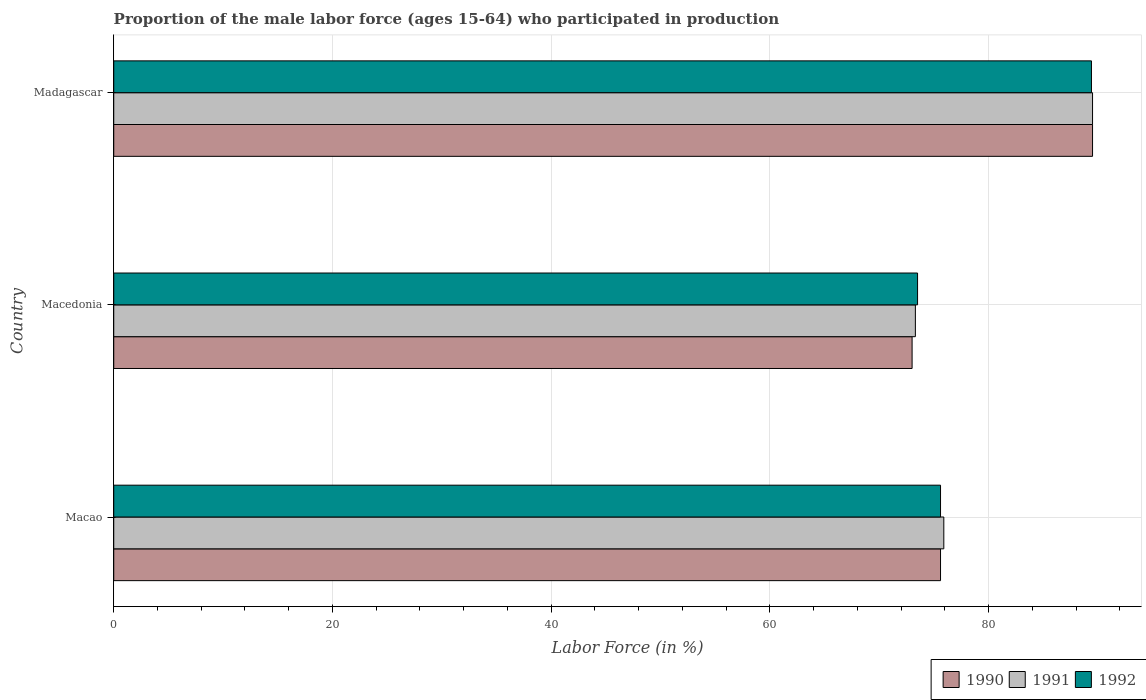How many different coloured bars are there?
Your answer should be compact. 3. Are the number of bars per tick equal to the number of legend labels?
Provide a short and direct response. Yes. Are the number of bars on each tick of the Y-axis equal?
Keep it short and to the point. Yes. How many bars are there on the 3rd tick from the top?
Offer a very short reply. 3. How many bars are there on the 3rd tick from the bottom?
Give a very brief answer. 3. What is the label of the 3rd group of bars from the top?
Offer a terse response. Macao. In how many cases, is the number of bars for a given country not equal to the number of legend labels?
Give a very brief answer. 0. What is the proportion of the male labor force who participated in production in 1991 in Macedonia?
Your answer should be very brief. 73.3. Across all countries, what is the maximum proportion of the male labor force who participated in production in 1991?
Give a very brief answer. 89.5. Across all countries, what is the minimum proportion of the male labor force who participated in production in 1992?
Offer a very short reply. 73.5. In which country was the proportion of the male labor force who participated in production in 1992 maximum?
Provide a succinct answer. Madagascar. In which country was the proportion of the male labor force who participated in production in 1990 minimum?
Make the answer very short. Macedonia. What is the total proportion of the male labor force who participated in production in 1991 in the graph?
Make the answer very short. 238.7. What is the difference between the proportion of the male labor force who participated in production in 1992 in Macedonia and that in Madagascar?
Give a very brief answer. -15.9. What is the difference between the proportion of the male labor force who participated in production in 1990 in Macao and the proportion of the male labor force who participated in production in 1992 in Madagascar?
Your response must be concise. -13.8. What is the average proportion of the male labor force who participated in production in 1990 per country?
Keep it short and to the point. 79.37. In how many countries, is the proportion of the male labor force who participated in production in 1991 greater than 44 %?
Your response must be concise. 3. What is the ratio of the proportion of the male labor force who participated in production in 1992 in Macedonia to that in Madagascar?
Provide a short and direct response. 0.82. What is the difference between the highest and the second highest proportion of the male labor force who participated in production in 1992?
Give a very brief answer. 13.8. What is the difference between the highest and the lowest proportion of the male labor force who participated in production in 1992?
Offer a very short reply. 15.9. Is the sum of the proportion of the male labor force who participated in production in 1990 in Macao and Macedonia greater than the maximum proportion of the male labor force who participated in production in 1992 across all countries?
Make the answer very short. Yes. What does the 2nd bar from the top in Madagascar represents?
Offer a very short reply. 1991. What does the 3rd bar from the bottom in Madagascar represents?
Your answer should be very brief. 1992. Is it the case that in every country, the sum of the proportion of the male labor force who participated in production in 1991 and proportion of the male labor force who participated in production in 1990 is greater than the proportion of the male labor force who participated in production in 1992?
Offer a very short reply. Yes. How many bars are there?
Your answer should be very brief. 9. How many countries are there in the graph?
Offer a terse response. 3. Are the values on the major ticks of X-axis written in scientific E-notation?
Your answer should be very brief. No. Does the graph contain any zero values?
Your answer should be compact. No. Does the graph contain grids?
Provide a succinct answer. Yes. How many legend labels are there?
Your response must be concise. 3. What is the title of the graph?
Offer a very short reply. Proportion of the male labor force (ages 15-64) who participated in production. Does "2014" appear as one of the legend labels in the graph?
Make the answer very short. No. What is the Labor Force (in %) in 1990 in Macao?
Offer a terse response. 75.6. What is the Labor Force (in %) in 1991 in Macao?
Provide a short and direct response. 75.9. What is the Labor Force (in %) of 1992 in Macao?
Provide a short and direct response. 75.6. What is the Labor Force (in %) of 1991 in Macedonia?
Give a very brief answer. 73.3. What is the Labor Force (in %) in 1992 in Macedonia?
Your response must be concise. 73.5. What is the Labor Force (in %) of 1990 in Madagascar?
Give a very brief answer. 89.5. What is the Labor Force (in %) of 1991 in Madagascar?
Make the answer very short. 89.5. What is the Labor Force (in %) of 1992 in Madagascar?
Your answer should be very brief. 89.4. Across all countries, what is the maximum Labor Force (in %) in 1990?
Your response must be concise. 89.5. Across all countries, what is the maximum Labor Force (in %) of 1991?
Your answer should be compact. 89.5. Across all countries, what is the maximum Labor Force (in %) of 1992?
Make the answer very short. 89.4. Across all countries, what is the minimum Labor Force (in %) of 1991?
Make the answer very short. 73.3. Across all countries, what is the minimum Labor Force (in %) in 1992?
Your answer should be very brief. 73.5. What is the total Labor Force (in %) of 1990 in the graph?
Your answer should be compact. 238.1. What is the total Labor Force (in %) of 1991 in the graph?
Provide a succinct answer. 238.7. What is the total Labor Force (in %) of 1992 in the graph?
Keep it short and to the point. 238.5. What is the difference between the Labor Force (in %) in 1991 in Macao and that in Macedonia?
Your answer should be compact. 2.6. What is the difference between the Labor Force (in %) of 1992 in Macao and that in Macedonia?
Give a very brief answer. 2.1. What is the difference between the Labor Force (in %) of 1990 in Macao and that in Madagascar?
Your response must be concise. -13.9. What is the difference between the Labor Force (in %) in 1991 in Macao and that in Madagascar?
Your response must be concise. -13.6. What is the difference between the Labor Force (in %) of 1990 in Macedonia and that in Madagascar?
Ensure brevity in your answer.  -16.5. What is the difference between the Labor Force (in %) in 1991 in Macedonia and that in Madagascar?
Offer a very short reply. -16.2. What is the difference between the Labor Force (in %) in 1992 in Macedonia and that in Madagascar?
Keep it short and to the point. -15.9. What is the difference between the Labor Force (in %) in 1990 in Macao and the Labor Force (in %) in 1991 in Macedonia?
Provide a short and direct response. 2.3. What is the difference between the Labor Force (in %) in 1990 in Macao and the Labor Force (in %) in 1992 in Macedonia?
Your answer should be very brief. 2.1. What is the difference between the Labor Force (in %) of 1991 in Macao and the Labor Force (in %) of 1992 in Macedonia?
Provide a short and direct response. 2.4. What is the difference between the Labor Force (in %) of 1990 in Macao and the Labor Force (in %) of 1992 in Madagascar?
Your response must be concise. -13.8. What is the difference between the Labor Force (in %) in 1991 in Macao and the Labor Force (in %) in 1992 in Madagascar?
Offer a terse response. -13.5. What is the difference between the Labor Force (in %) in 1990 in Macedonia and the Labor Force (in %) in 1991 in Madagascar?
Provide a succinct answer. -16.5. What is the difference between the Labor Force (in %) in 1990 in Macedonia and the Labor Force (in %) in 1992 in Madagascar?
Offer a terse response. -16.4. What is the difference between the Labor Force (in %) of 1991 in Macedonia and the Labor Force (in %) of 1992 in Madagascar?
Your answer should be very brief. -16.1. What is the average Labor Force (in %) of 1990 per country?
Your response must be concise. 79.37. What is the average Labor Force (in %) of 1991 per country?
Offer a terse response. 79.57. What is the average Labor Force (in %) in 1992 per country?
Offer a very short reply. 79.5. What is the difference between the Labor Force (in %) in 1990 and Labor Force (in %) in 1992 in Macao?
Your response must be concise. 0. What is the difference between the Labor Force (in %) in 1991 and Labor Force (in %) in 1992 in Macao?
Keep it short and to the point. 0.3. What is the difference between the Labor Force (in %) of 1990 and Labor Force (in %) of 1992 in Macedonia?
Your response must be concise. -0.5. What is the difference between the Labor Force (in %) of 1990 and Labor Force (in %) of 1992 in Madagascar?
Offer a terse response. 0.1. What is the difference between the Labor Force (in %) in 1991 and Labor Force (in %) in 1992 in Madagascar?
Keep it short and to the point. 0.1. What is the ratio of the Labor Force (in %) of 1990 in Macao to that in Macedonia?
Your answer should be compact. 1.04. What is the ratio of the Labor Force (in %) of 1991 in Macao to that in Macedonia?
Offer a very short reply. 1.04. What is the ratio of the Labor Force (in %) of 1992 in Macao to that in Macedonia?
Make the answer very short. 1.03. What is the ratio of the Labor Force (in %) in 1990 in Macao to that in Madagascar?
Offer a very short reply. 0.84. What is the ratio of the Labor Force (in %) of 1991 in Macao to that in Madagascar?
Ensure brevity in your answer.  0.85. What is the ratio of the Labor Force (in %) of 1992 in Macao to that in Madagascar?
Ensure brevity in your answer.  0.85. What is the ratio of the Labor Force (in %) in 1990 in Macedonia to that in Madagascar?
Give a very brief answer. 0.82. What is the ratio of the Labor Force (in %) of 1991 in Macedonia to that in Madagascar?
Offer a very short reply. 0.82. What is the ratio of the Labor Force (in %) of 1992 in Macedonia to that in Madagascar?
Your response must be concise. 0.82. What is the difference between the highest and the lowest Labor Force (in %) of 1990?
Offer a very short reply. 16.5. What is the difference between the highest and the lowest Labor Force (in %) of 1992?
Your answer should be very brief. 15.9. 